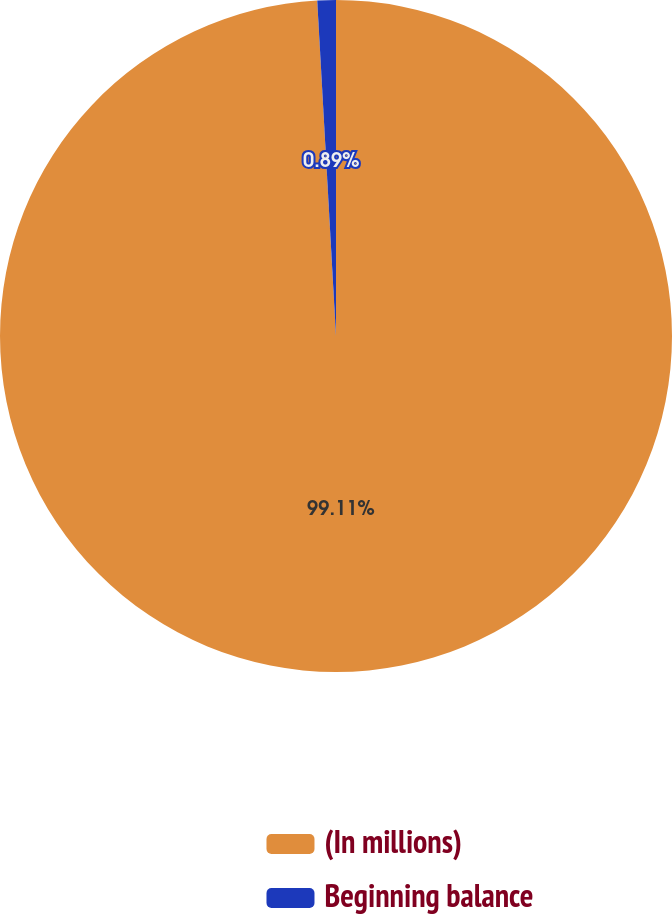<chart> <loc_0><loc_0><loc_500><loc_500><pie_chart><fcel>(In millions)<fcel>Beginning balance<nl><fcel>99.11%<fcel>0.89%<nl></chart> 